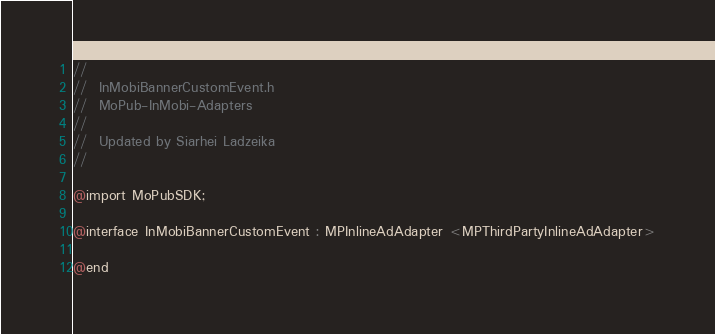Convert code to text. <code><loc_0><loc_0><loc_500><loc_500><_C_>//
//  InMobiBannerCustomEvent.h
//  MoPub-InMobi-Adapters
//
//  Updated by Siarhei Ladzeika
//

@import MoPubSDK;

@interface InMobiBannerCustomEvent : MPInlineAdAdapter <MPThirdPartyInlineAdAdapter>

@end
</code> 